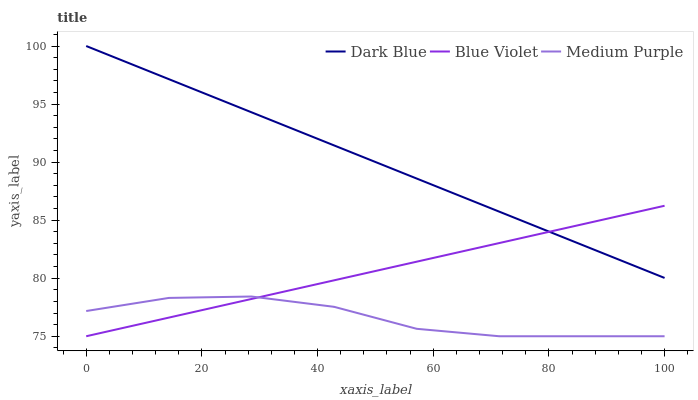Does Medium Purple have the minimum area under the curve?
Answer yes or no. Yes. Does Dark Blue have the maximum area under the curve?
Answer yes or no. Yes. Does Blue Violet have the minimum area under the curve?
Answer yes or no. No. Does Blue Violet have the maximum area under the curve?
Answer yes or no. No. Is Blue Violet the smoothest?
Answer yes or no. Yes. Is Medium Purple the roughest?
Answer yes or no. Yes. Is Dark Blue the smoothest?
Answer yes or no. No. Is Dark Blue the roughest?
Answer yes or no. No. Does Medium Purple have the lowest value?
Answer yes or no. Yes. Does Dark Blue have the lowest value?
Answer yes or no. No. Does Dark Blue have the highest value?
Answer yes or no. Yes. Does Blue Violet have the highest value?
Answer yes or no. No. Is Medium Purple less than Dark Blue?
Answer yes or no. Yes. Is Dark Blue greater than Medium Purple?
Answer yes or no. Yes. Does Dark Blue intersect Blue Violet?
Answer yes or no. Yes. Is Dark Blue less than Blue Violet?
Answer yes or no. No. Is Dark Blue greater than Blue Violet?
Answer yes or no. No. Does Medium Purple intersect Dark Blue?
Answer yes or no. No. 